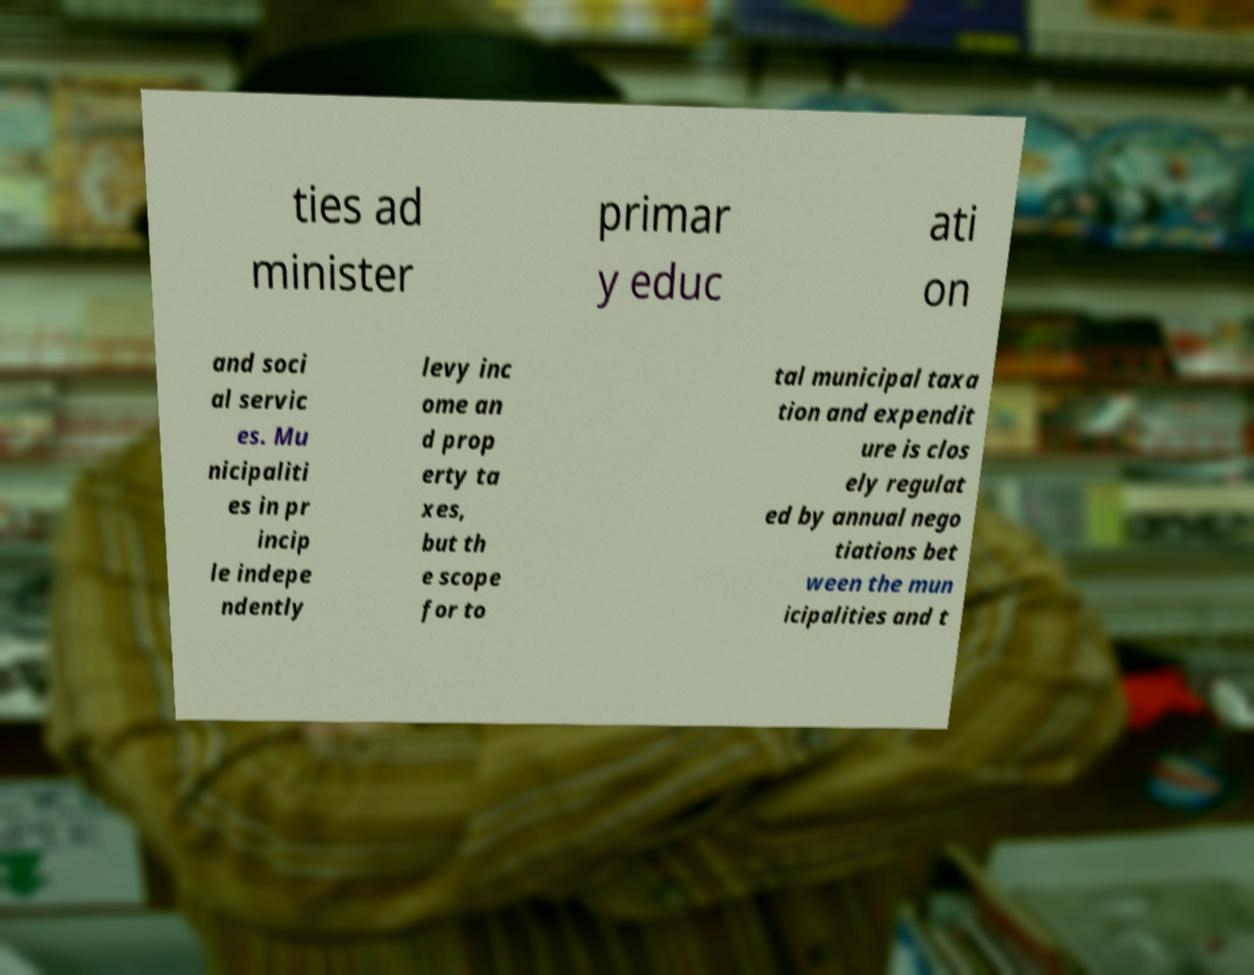Can you accurately transcribe the text from the provided image for me? ties ad minister primar y educ ati on and soci al servic es. Mu nicipaliti es in pr incip le indepe ndently levy inc ome an d prop erty ta xes, but th e scope for to tal municipal taxa tion and expendit ure is clos ely regulat ed by annual nego tiations bet ween the mun icipalities and t 